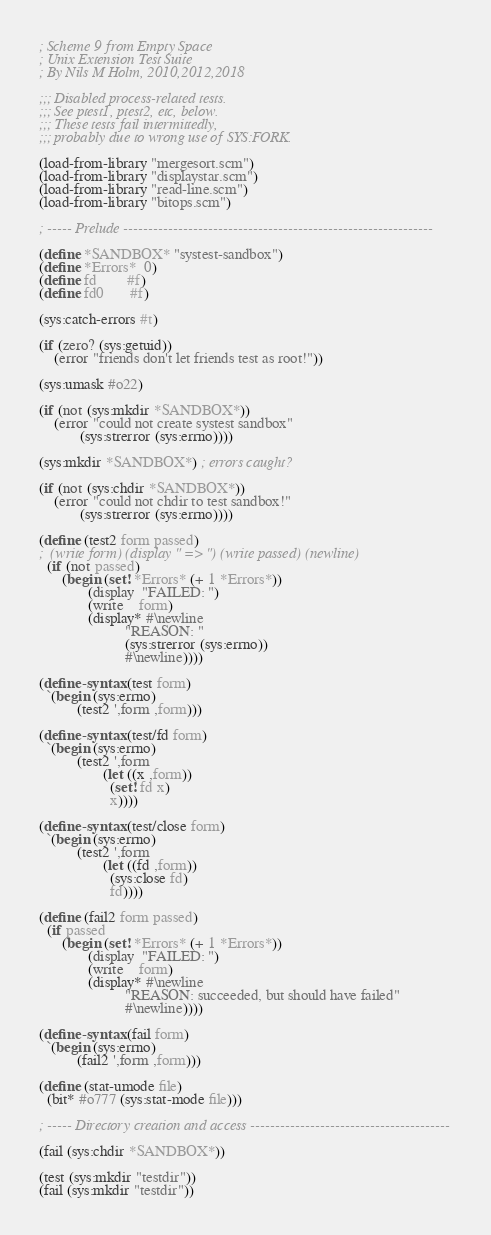Convert code to text. <code><loc_0><loc_0><loc_500><loc_500><_Scheme_>; Scheme 9 from Empty Space
; Unix Extension Test Suite
; By Nils M Holm, 2010,2012,2018

;;; Disabled process-related tests.
;;; See ptest1, ptest2, etc, below.
;;; These tests fail intermittedly,
;;; probably due to wrong use of SYS:FORK.

(load-from-library "mergesort.scm")
(load-from-library "displaystar.scm")
(load-from-library "read-line.scm")
(load-from-library "bitops.scm")

; ----- Prelude --------------------------------------------------------------

(define *SANDBOX* "systest-sandbox")
(define *Errors*  0)
(define fd        #f)
(define fd0       #f)

(sys:catch-errors #t)

(if (zero? (sys:getuid))
    (error "friends don't let friends test as root!"))

(sys:umask #o22)

(if (not (sys:mkdir *SANDBOX*))
    (error "could not create systest sandbox"
           (sys:strerror (sys:errno))))

(sys:mkdir *SANDBOX*) ; errors caught?

(if (not (sys:chdir *SANDBOX*))
    (error "could not chdir to test sandbox!"
           (sys:strerror (sys:errno))))

(define (test2 form passed)
;  (write form) (display " => ") (write passed) (newline)
  (if (not passed)
      (begin (set! *Errors* (+ 1 *Errors*))
             (display  "FAILED: ")
             (write    form)
             (display* #\newline
                       "REASON: "
                       (sys:strerror (sys:errno))
                       #\newline))))

(define-syntax (test form)
  `(begin (sys:errno)
          (test2 ',form ,form)))

(define-syntax (test/fd form)
  `(begin (sys:errno)
          (test2 ',form
                 (let ((x ,form))
                   (set! fd x)
                   x))))

(define-syntax (test/close form)
  `(begin (sys:errno)
          (test2 ',form
                 (let ((fd ,form))
                   (sys:close fd)
                   fd))))

(define (fail2 form passed)
  (if passed
      (begin (set! *Errors* (+ 1 *Errors*))
             (display  "FAILED: ")
             (write    form)
             (display* #\newline
                       "REASON: succeeded, but should have failed"
                       #\newline))))

(define-syntax (fail form)
  `(begin (sys:errno)
          (fail2 ',form ,form)))

(define (stat-umode file)
  (bit* #o777 (sys:stat-mode file)))

; ----- Directory creation and access ----------------------------------------

(fail (sys:chdir *SANDBOX*))

(test (sys:mkdir "testdir"))
(fail (sys:mkdir "testdir"))
</code> 